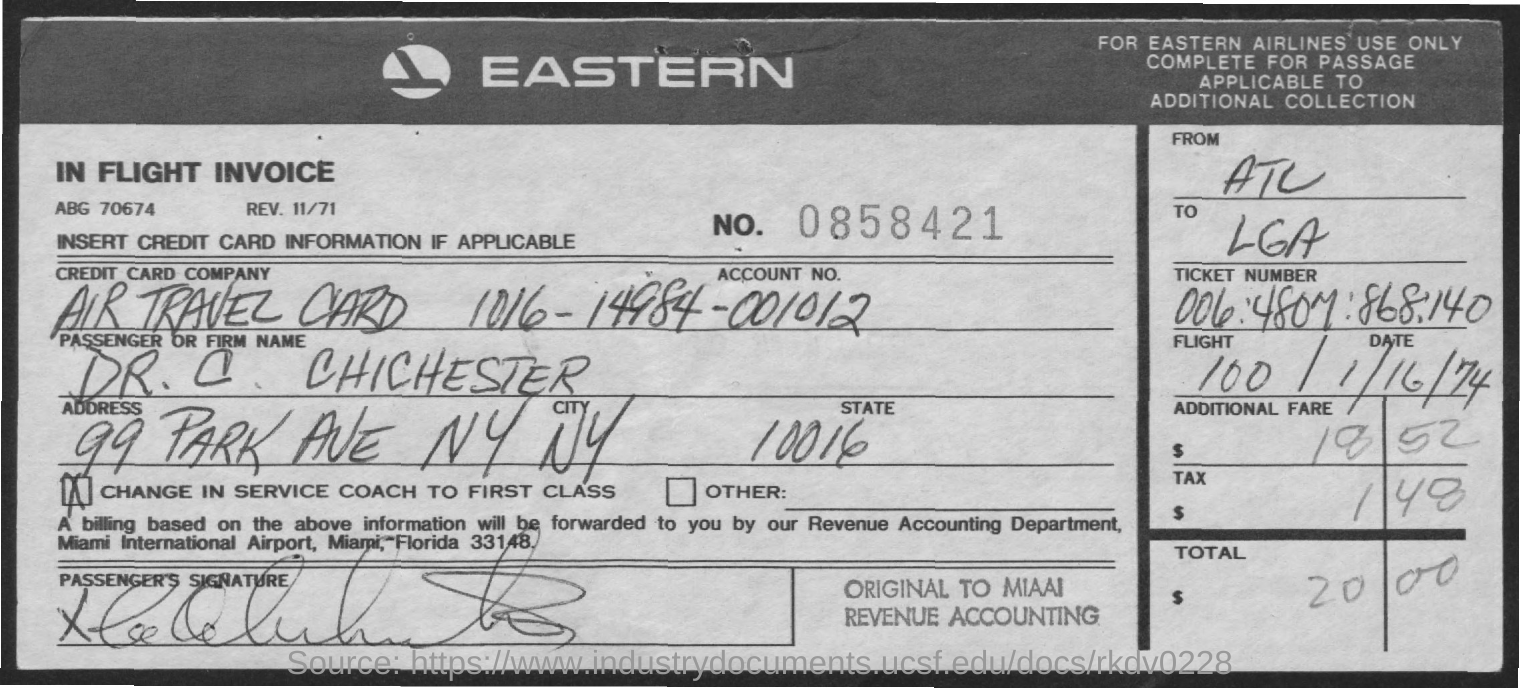Which is the Credit card company?
Ensure brevity in your answer.  Air travel card. What is the Account No.?
Your answer should be compact. 1016-14984-001012. What is the Address?
Provide a short and direct response. 99 Park Ave NY. What is the Passenger or firm name?
Offer a very short reply. Dr. c. chichester. 